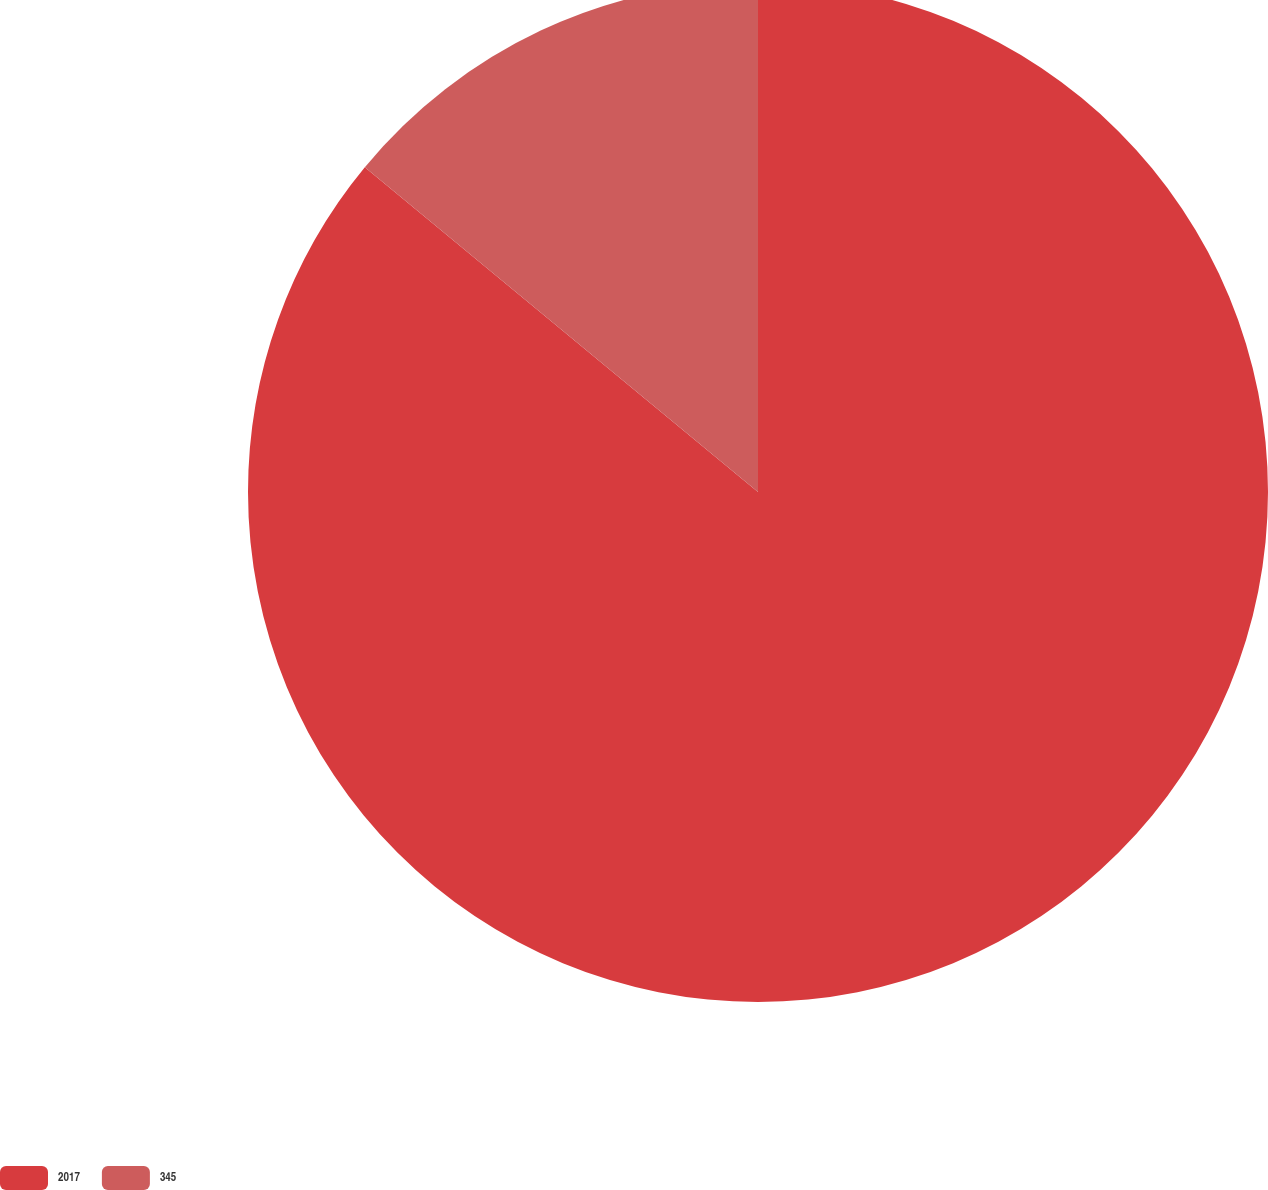Convert chart to OTSL. <chart><loc_0><loc_0><loc_500><loc_500><pie_chart><fcel>2017<fcel>345<nl><fcel>85.99%<fcel>14.01%<nl></chart> 